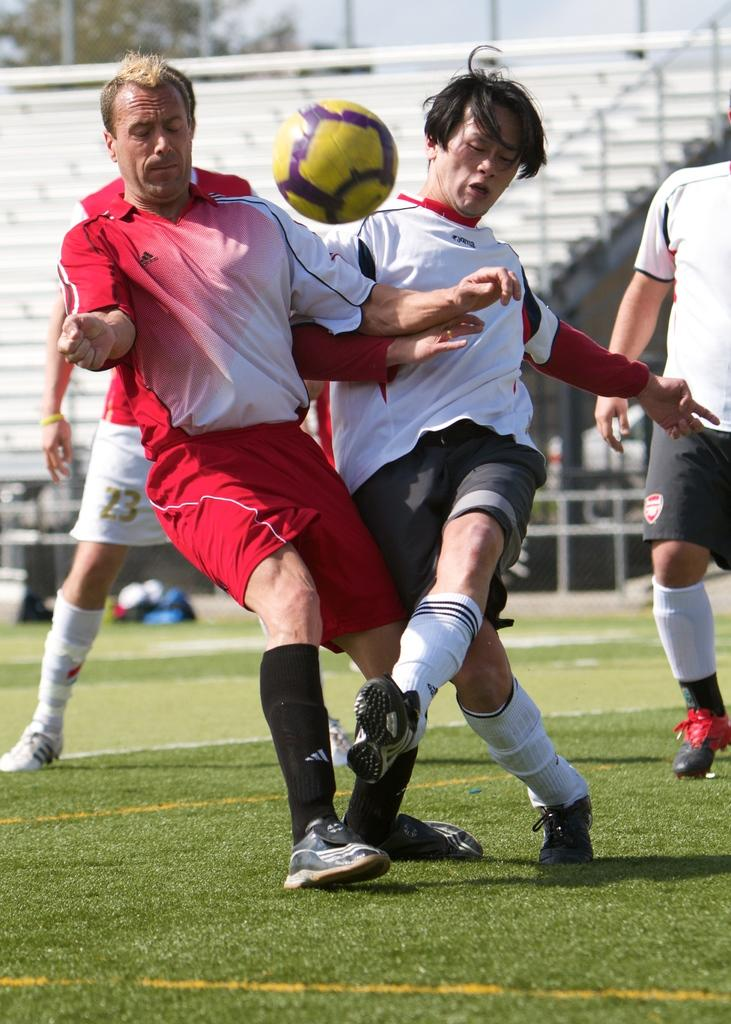What activity are the persons in the image engaged in? The persons in the image are playing football. What color is the football in the image? The football in the image is yellow. What type of surface are the persons playing on? There is green grass at the bottom of the image, which is the surface they are playing on. What architectural feature can be seen in the background of the image? There are steps in the background of the image. How many apples are being picked by the beginner farmer in the image? There are no apples or farmers present in the image; it features persons playing football on a grassy surface with a yellow ball. 